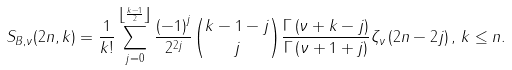Convert formula to latex. <formula><loc_0><loc_0><loc_500><loc_500>S _ { B , \nu } ( 2 n , k ) = \frac { 1 } { k ! } \sum _ { j = 0 } ^ { \left \lfloor \frac { k - 1 } { 2 } \right \rfloor } \frac { \left ( - 1 \right ) ^ { j } } { 2 ^ { 2 j } } \binom { k - 1 - j } { j } \frac { \Gamma \left ( \nu + k - j \right ) } { \Gamma \left ( \nu + 1 + j \right ) } \zeta _ { \nu } \left ( 2 n - 2 j \right ) , \, k \leq n .</formula> 